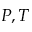Convert formula to latex. <formula><loc_0><loc_0><loc_500><loc_500>P , T</formula> 